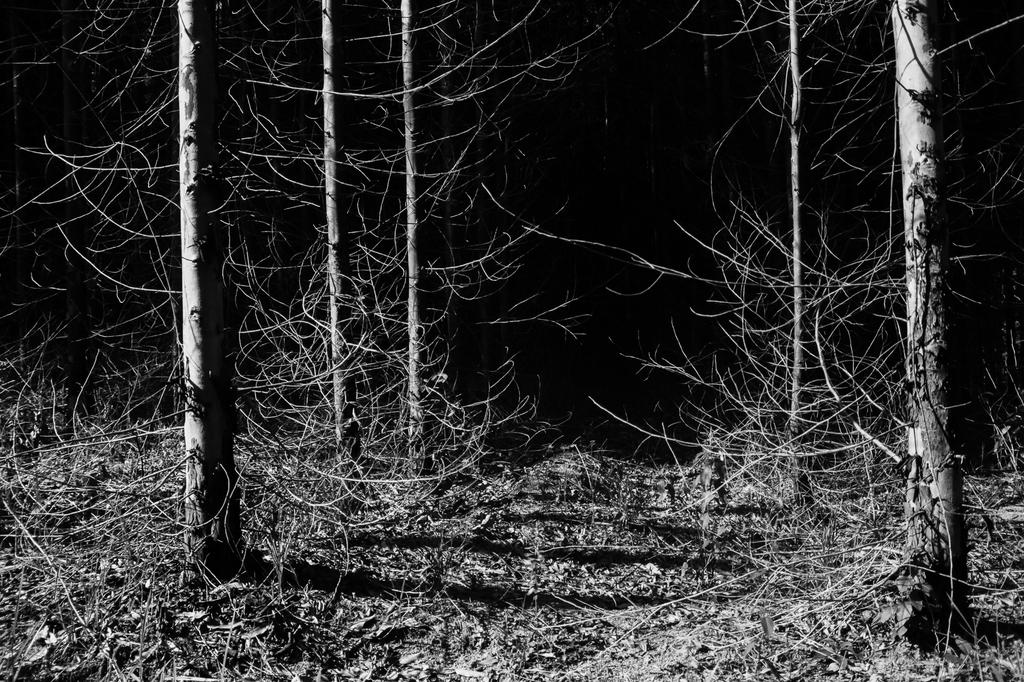What type of vegetation is present in the image? There are dry trees in the image. What is the color scheme of the image? The image is in black and white. What type of rice can be seen being sorted in the image? There is no rice present in the image, and therefore no sorting activity can be observed. 